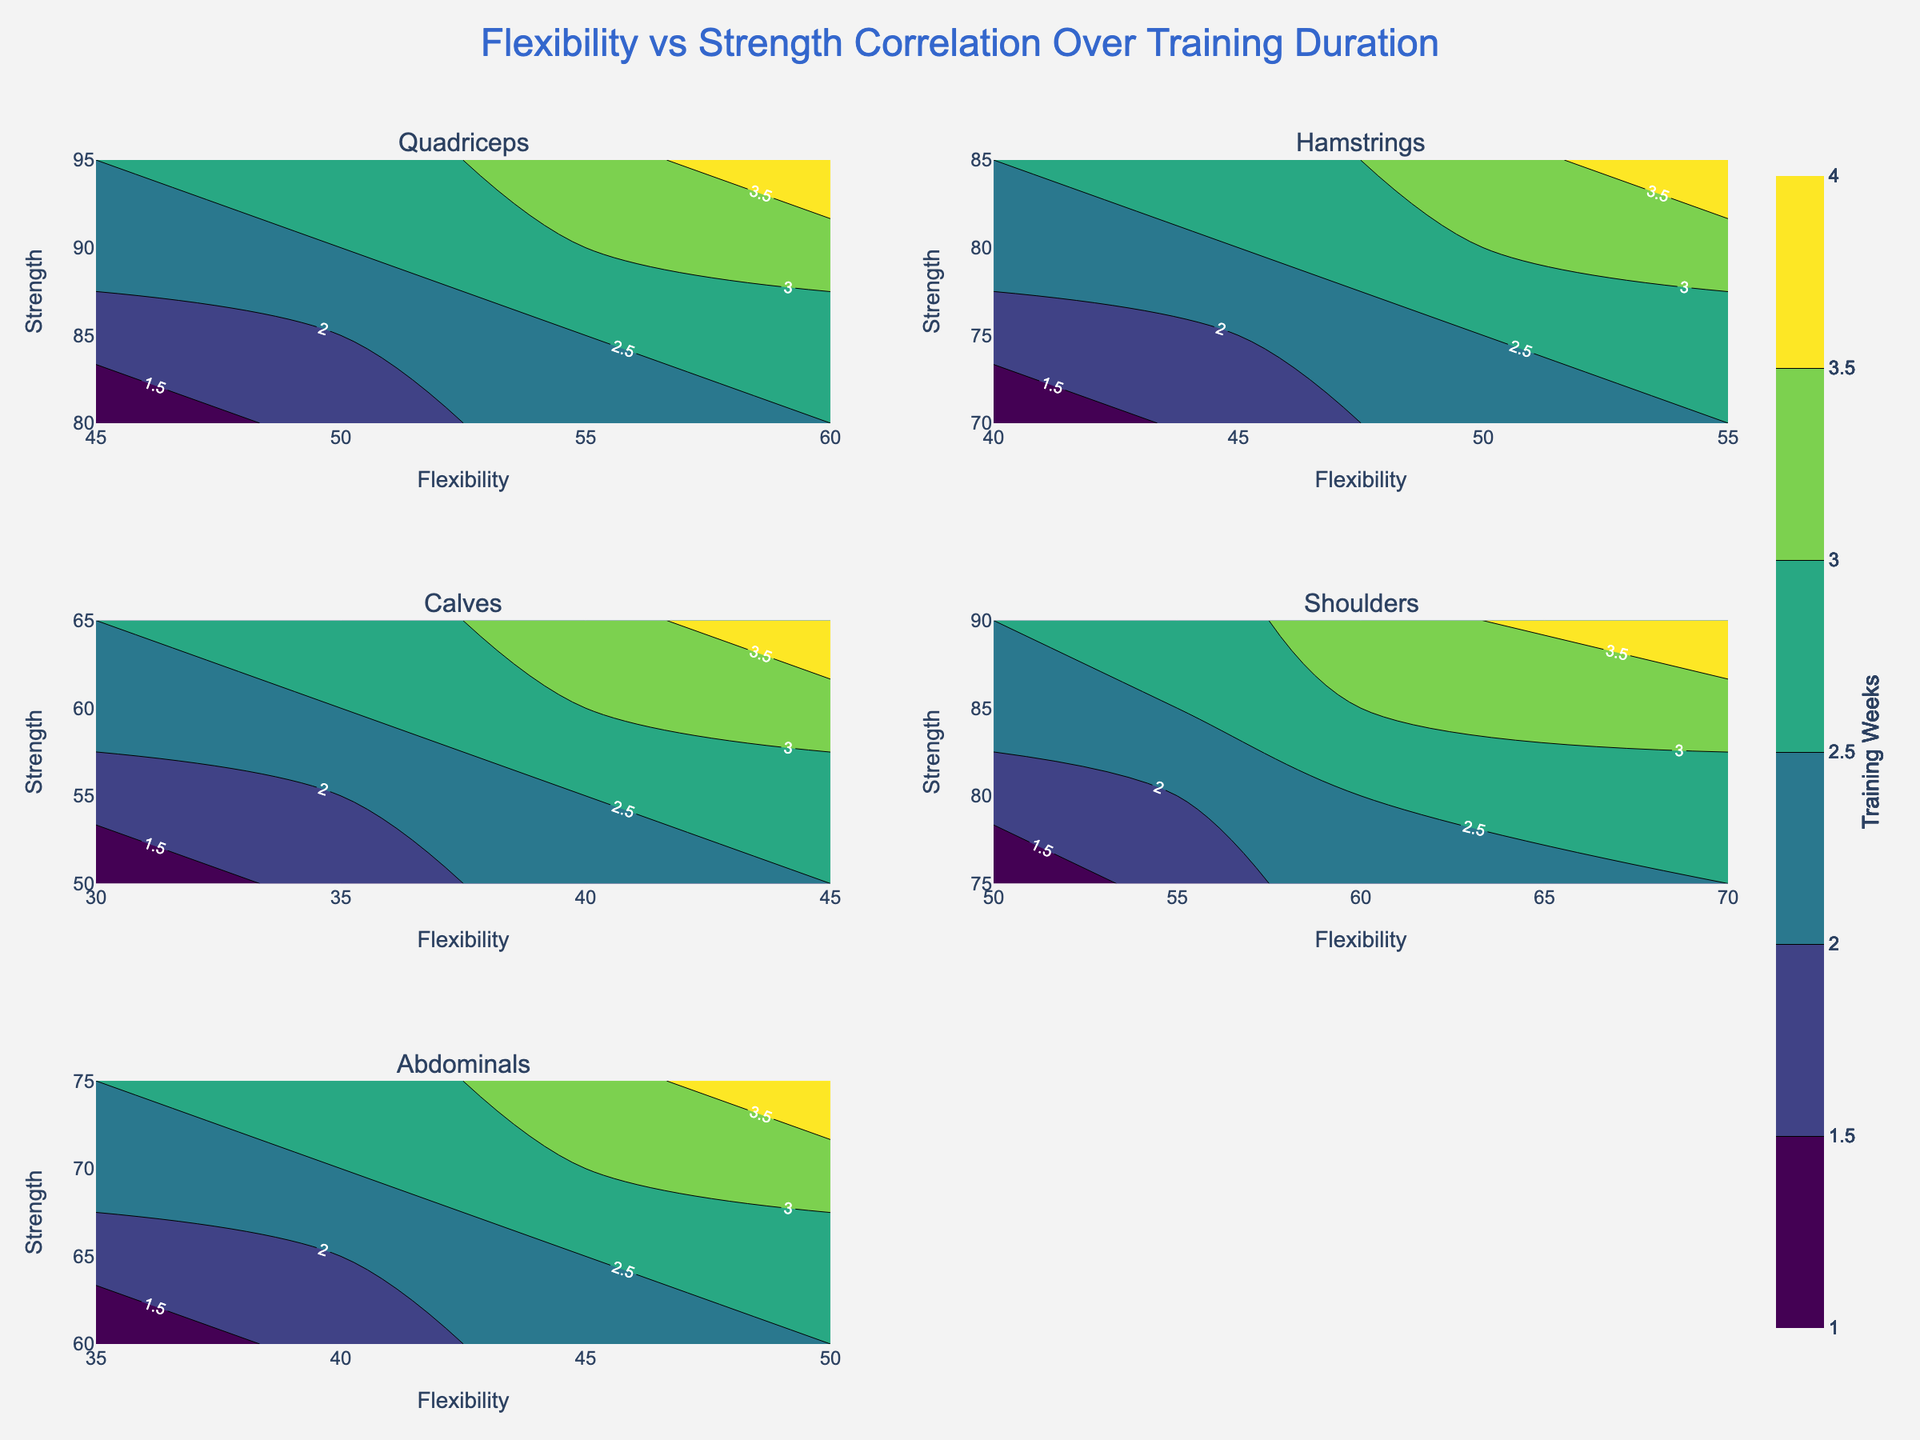What is the title of the figure? The title of the figure is usually located at the top center of the chart.
Answer: Flexibility vs Strength Correlation Over Training Duration Which muscle group shows the highest flexibility value? To determine this, look across all subplots and identify the contour plot that extends the furthest to the right along the x-axis (Flexibility axis).
Answer: Shoulders How does the strength of the Hamstrings vary with flexibility? In the subplot for Hamstrings, observe the contour lines to see how they trend as flexibility increases.
Answer: Strength increases with flexibility Which muscle group has the lowest strength value in the first week of training? For each subplot, look at the contour labels at the lowest flexibility where z=1 (Training Week).
Answer: Calves Compare the training duration contour labels between Quadriceps and Abdominals. Which group shows a higher training duration at a similar flexibility and strength level? Compare the contour lines for similar flexibility and strength ranges in both subplots to see which has higher training durations labeled.
Answer: Quadriceps What is the color associated with the highest values of training weeks? Refer to the color scale legend on the figure to determine the color associated with the highest values.
Answer: Yellow (or the lightest color on the Viridis scale) Which muscle group shows a constant increment in strength with increasing flexibility? Inspect the contour plots for each muscle, looking for a subplot where contour lines consistently increase in strength values as flexibility increases.
Answer: Quadriceps In which muscle groups does the correlation between flexibility and strength appear to be the strongest? Look at the subplots to see where the contour lines are most closely spaced, indicating a stronger correlation.
Answer: Quadriceps and Shoulders What trend can you observe in the Abdominals subplot for training duration as flexibility increases? Analyze the contours in the Abdominals subplot to see how the training duration labels change with increasing flexibility.
Answer: Training duration increases with flexibility 